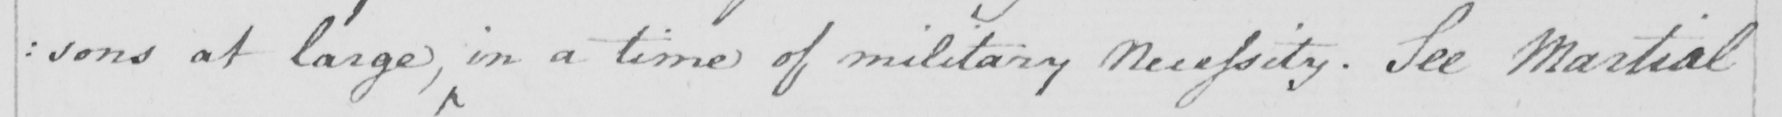Can you tell me what this handwritten text says? : sons at large , in a time of military Necessity . See Martial 